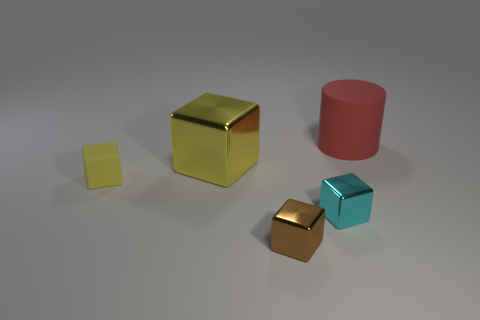Is the material of the cylinder the same as the cyan block?
Offer a terse response. No. Is there anything else that has the same shape as the big matte object?
Offer a very short reply. No. Is the yellow object that is behind the matte block made of the same material as the block that is to the right of the tiny brown cube?
Give a very brief answer. Yes. What material is the large yellow object?
Offer a terse response. Metal. What number of tiny yellow objects have the same material as the big yellow block?
Provide a succinct answer. 0. How many matte objects are either cyan things or balls?
Your answer should be compact. 0. Do the tiny thing that is to the right of the tiny brown thing and the yellow object behind the small yellow thing have the same shape?
Offer a very short reply. Yes. The metallic object that is behind the small brown thing and in front of the yellow rubber thing is what color?
Provide a succinct answer. Cyan. There is a rubber thing left of the big red cylinder; is its size the same as the rubber object behind the tiny yellow object?
Give a very brief answer. No. What number of metal objects have the same color as the tiny rubber block?
Your response must be concise. 1. 